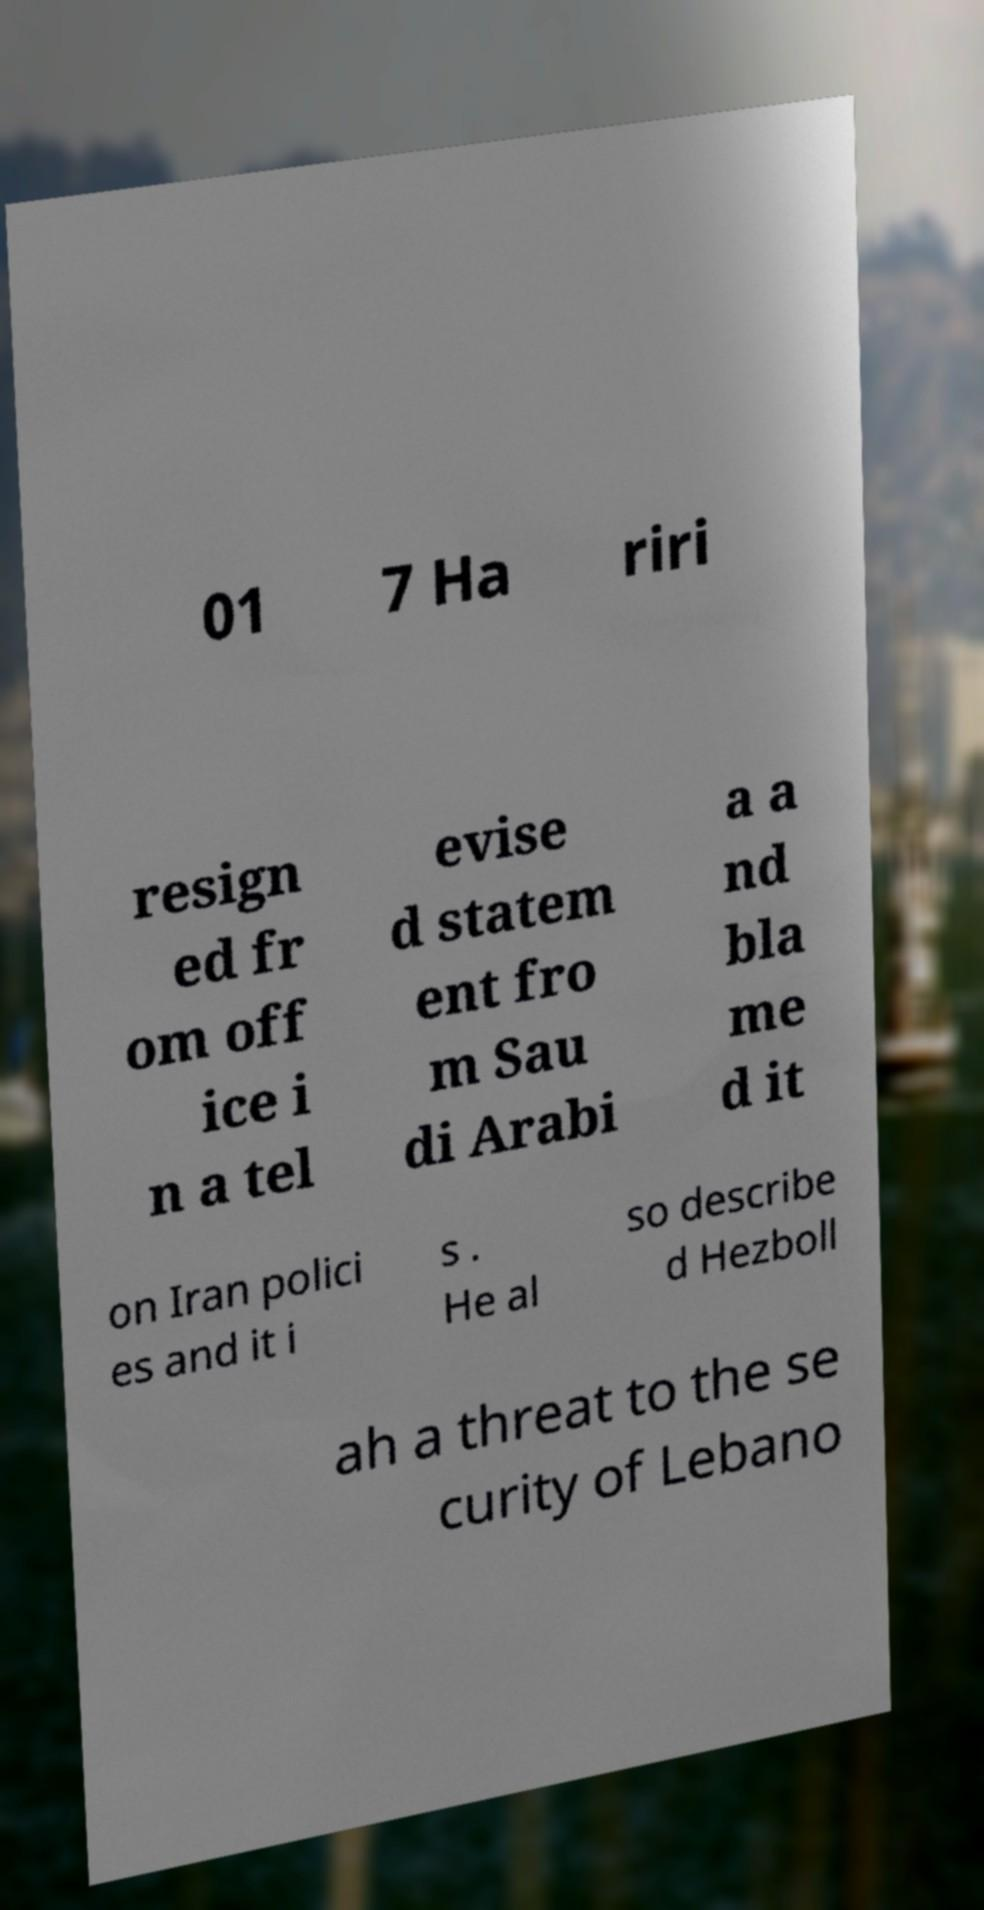Can you accurately transcribe the text from the provided image for me? 01 7 Ha riri resign ed fr om off ice i n a tel evise d statem ent fro m Sau di Arabi a a nd bla me d it on Iran polici es and it i s . He al so describe d Hezboll ah a threat to the se curity of Lebano 